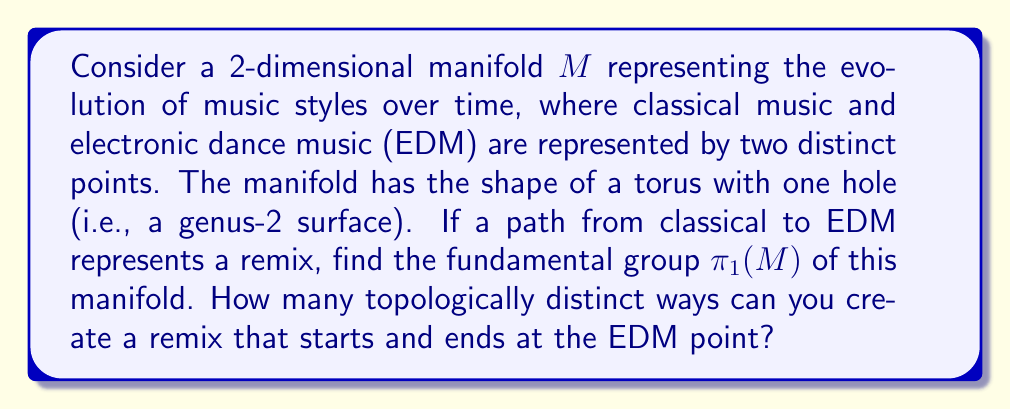Provide a solution to this math problem. To solve this problem, we need to understand the fundamental group of a genus-2 surface:

1) The fundamental group of a genus-g surface is given by:

   $$\pi_1(M_g) = \langle a_1, b_1, \ldots, a_g, b_g \mid [a_1,b_1]\cdots[a_g,b_g] = 1 \rangle$$

   where $[a,b] = aba^{-1}b^{-1}$ is the commutator.

2) For a genus-2 surface (g = 2), we have:

   $$\pi_1(M_2) = \langle a_1, b_1, a_2, b_2 \mid [a_1,b_1][a_2,b_2] = 1 \rangle$$

3) This group is free on 4 generators with one relation. It can be visualized as follows:

   [asy]
   import geometry;
   
   size(200);
   
   path p = circle((0,0),1);
   filldraw(p,lightgray);
   
   draw((-.8,-.6)--(.8,-.6)--(1.2,.6)--(-.4,.6)--cycle);
   draw((-.8,-.4)--(.8,-.4)--(1.2,.4)--(-.4,.4)--cycle);
   
   label("$a_1$", (0,.9));
   label("$b_1$", (.9,0));
   label("$a_2$", (0,-.9));
   label("$b_2$", (-.9,0));
   [/asy]

4) Each generator represents a loop around one of the holes or handles of the surface.

5) To count topologically distinct remixes starting and ending at the EDM point, we need to count the number of words in this group that are not homotopic to each other.

6) In this free group with 4 generators, any word that doesn't reduce to the identity represents a distinct path. The number of such words is infinite, as we can create arbitrarily long words by combining the generators and their inverses in different ways.

Therefore, there are infinitely many topologically distinct ways to create a remix that starts and ends at the EDM point on this manifold.
Answer: The fundamental group is $\pi_1(M) = \langle a_1, b_1, a_2, b_2 \mid [a_1,b_1][a_2,b_2] = 1 \rangle$, and there are infinitely many topologically distinct ways to create a remix that starts and ends at the EDM point. 